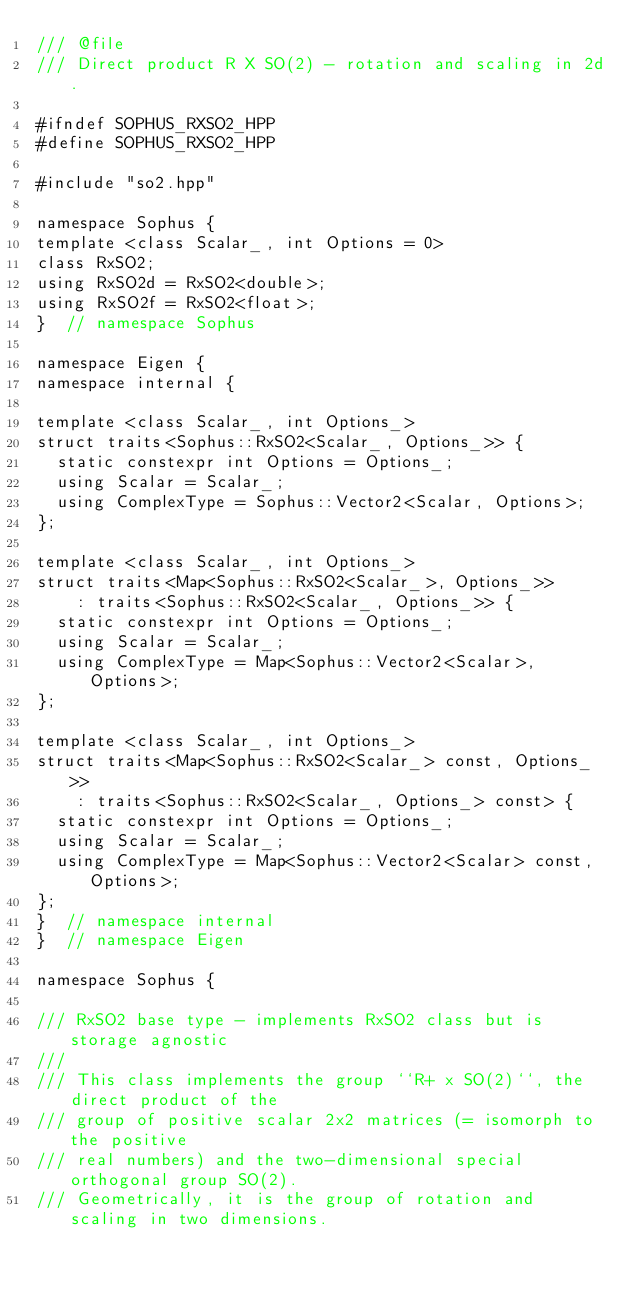Convert code to text. <code><loc_0><loc_0><loc_500><loc_500><_C++_>/// @file
/// Direct product R X SO(2) - rotation and scaling in 2d.

#ifndef SOPHUS_RXSO2_HPP
#define SOPHUS_RXSO2_HPP

#include "so2.hpp"

namespace Sophus {
template <class Scalar_, int Options = 0>
class RxSO2;
using RxSO2d = RxSO2<double>;
using RxSO2f = RxSO2<float>;
}  // namespace Sophus

namespace Eigen {
namespace internal {

template <class Scalar_, int Options_>
struct traits<Sophus::RxSO2<Scalar_, Options_>> {
  static constexpr int Options = Options_;
  using Scalar = Scalar_;
  using ComplexType = Sophus::Vector2<Scalar, Options>;
};

template <class Scalar_, int Options_>
struct traits<Map<Sophus::RxSO2<Scalar_>, Options_>>
    : traits<Sophus::RxSO2<Scalar_, Options_>> {
  static constexpr int Options = Options_;
  using Scalar = Scalar_;
  using ComplexType = Map<Sophus::Vector2<Scalar>, Options>;
};

template <class Scalar_, int Options_>
struct traits<Map<Sophus::RxSO2<Scalar_> const, Options_>>
    : traits<Sophus::RxSO2<Scalar_, Options_> const> {
  static constexpr int Options = Options_;
  using Scalar = Scalar_;
  using ComplexType = Map<Sophus::Vector2<Scalar> const, Options>;
};
}  // namespace internal
}  // namespace Eigen

namespace Sophus {

/// RxSO2 base type - implements RxSO2 class but is storage agnostic
///
/// This class implements the group ``R+ x SO(2)``, the direct product of the
/// group of positive scalar 2x2 matrices (= isomorph to the positive
/// real numbers) and the two-dimensional special orthogonal group SO(2).
/// Geometrically, it is the group of rotation and scaling in two dimensions.</code> 